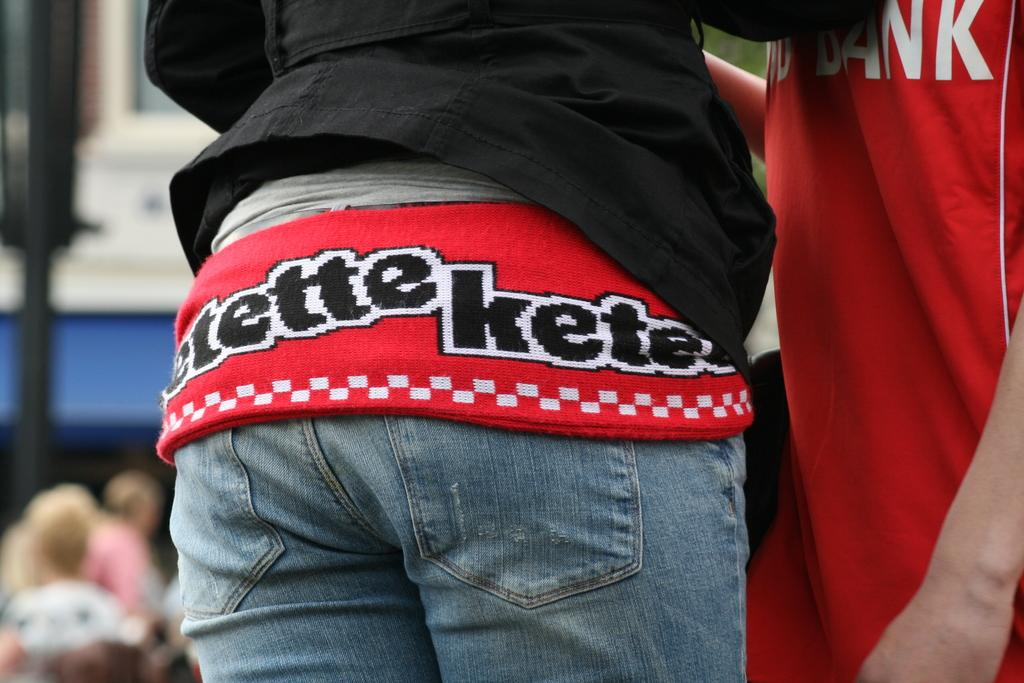<image>
Give a short and clear explanation of the subsequent image. a person's jeans and their shirt that says etette kete on it 